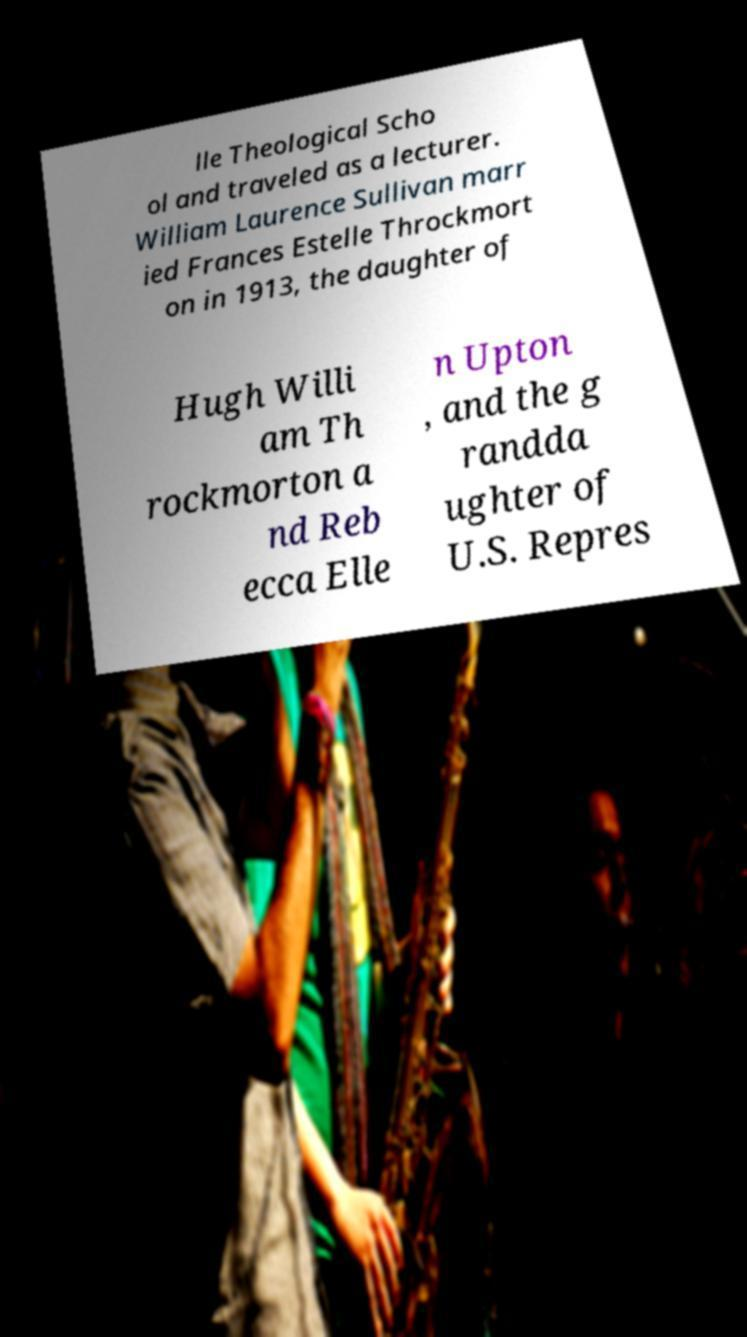Please read and relay the text visible in this image. What does it say? lle Theological Scho ol and traveled as a lecturer. William Laurence Sullivan marr ied Frances Estelle Throckmort on in 1913, the daughter of Hugh Willi am Th rockmorton a nd Reb ecca Elle n Upton , and the g randda ughter of U.S. Repres 